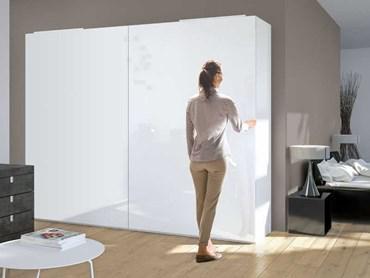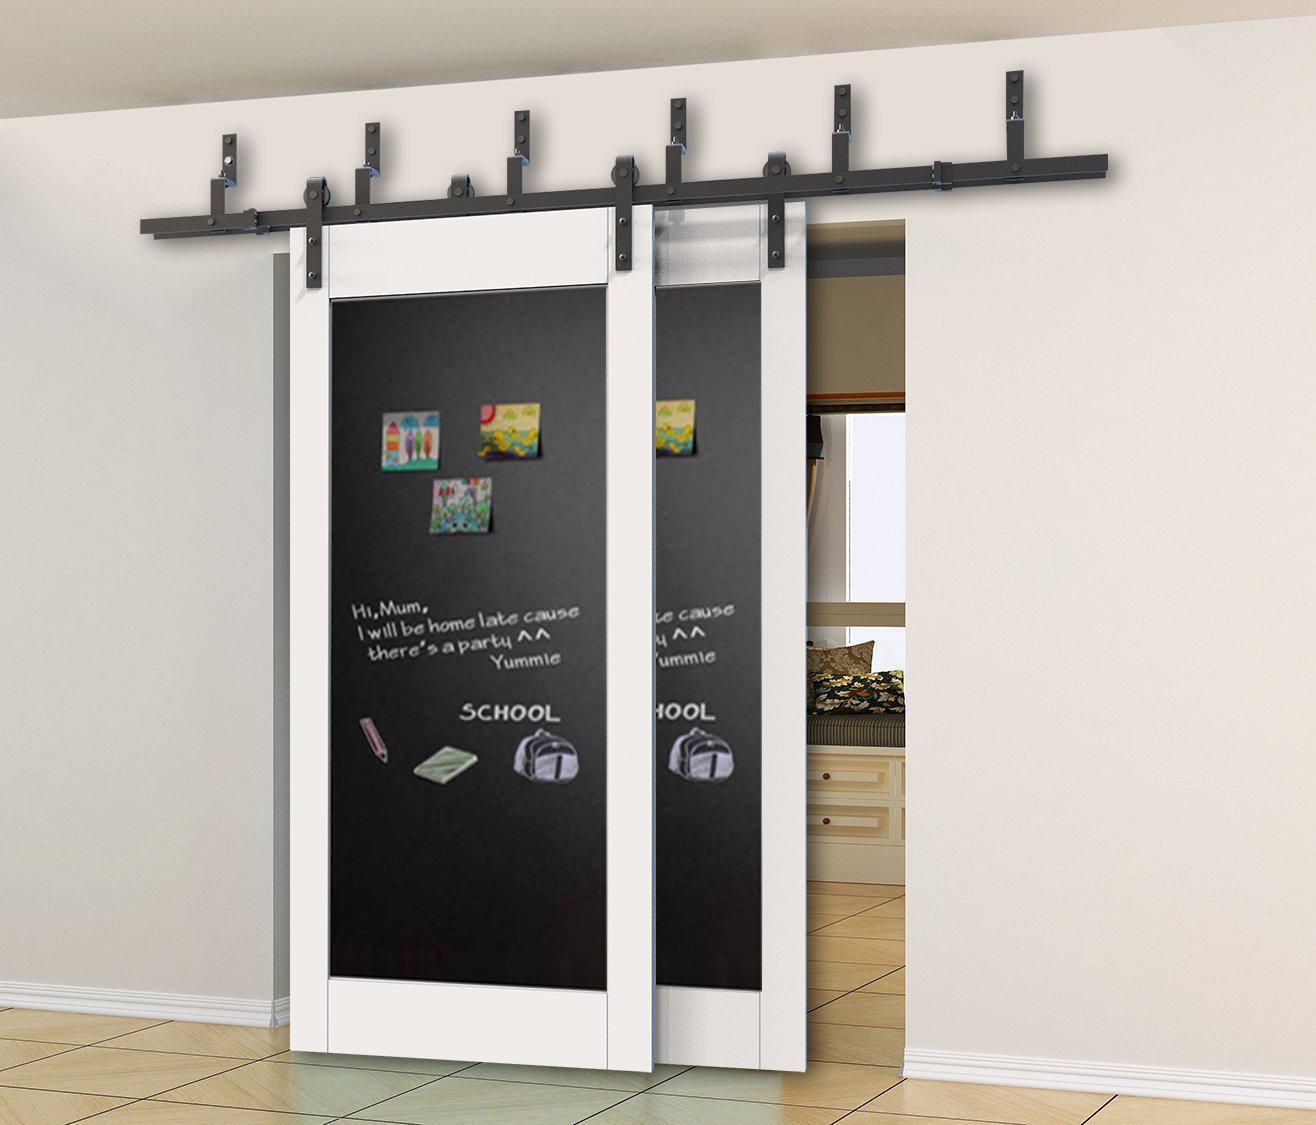The first image is the image on the left, the second image is the image on the right. For the images shown, is this caption "A woman is standing by the opening in the image on the left." true? Answer yes or no. Yes. The first image is the image on the left, the second image is the image on the right. Evaluate the accuracy of this statement regarding the images: "An image shows one woman standing and touching a sliding door element.". Is it true? Answer yes or no. Yes. 